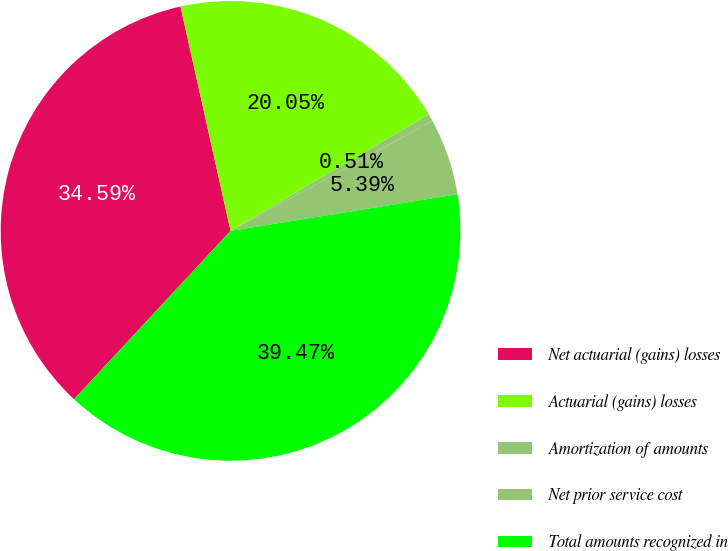<chart> <loc_0><loc_0><loc_500><loc_500><pie_chart><fcel>Net actuarial (gains) losses<fcel>Actuarial (gains) losses<fcel>Amortization of amounts<fcel>Net prior service cost<fcel>Total amounts recognized in<nl><fcel>34.59%<fcel>20.05%<fcel>0.51%<fcel>5.39%<fcel>39.47%<nl></chart> 